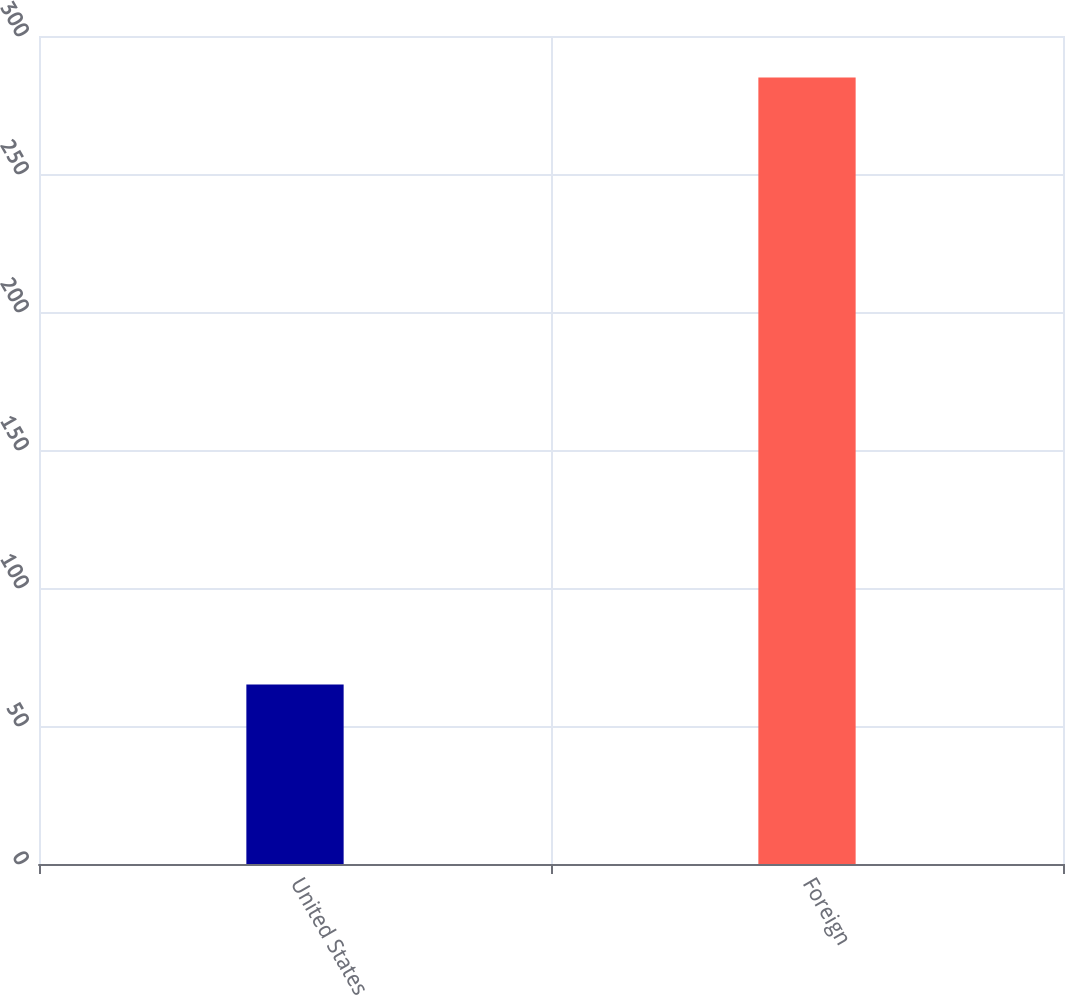Convert chart to OTSL. <chart><loc_0><loc_0><loc_500><loc_500><bar_chart><fcel>United States<fcel>Foreign<nl><fcel>65<fcel>285<nl></chart> 